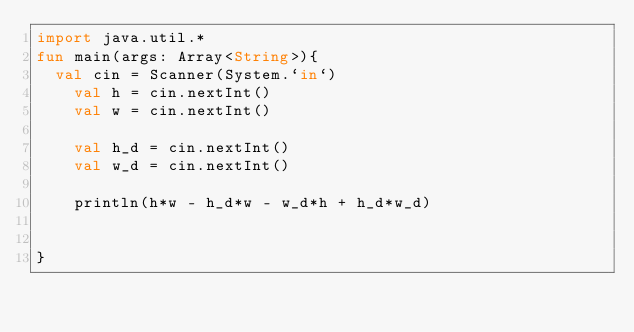Convert code to text. <code><loc_0><loc_0><loc_500><loc_500><_Kotlin_>import java.util.*
fun main(args: Array<String>){
	val cin = Scanner(System.`in`)
    val h = cin.nextInt()
    val w = cin.nextInt()

    val h_d = cin.nextInt()
    val w_d = cin.nextInt()

    println(h*w - h_d*w - w_d*h + h_d*w_d)
    
    
}</code> 